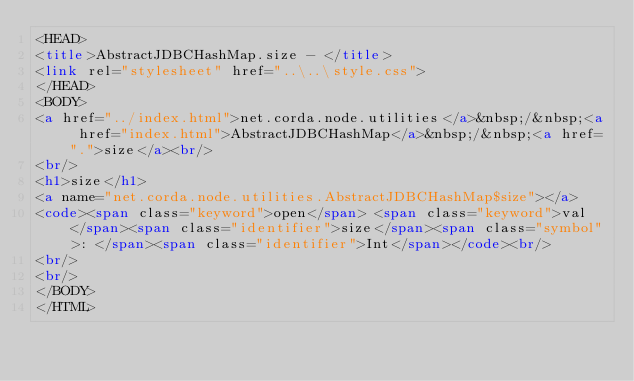Convert code to text. <code><loc_0><loc_0><loc_500><loc_500><_HTML_><HEAD>
<title>AbstractJDBCHashMap.size - </title>
<link rel="stylesheet" href="..\..\style.css">
</HEAD>
<BODY>
<a href="../index.html">net.corda.node.utilities</a>&nbsp;/&nbsp;<a href="index.html">AbstractJDBCHashMap</a>&nbsp;/&nbsp;<a href=".">size</a><br/>
<br/>
<h1>size</h1>
<a name="net.corda.node.utilities.AbstractJDBCHashMap$size"></a>
<code><span class="keyword">open</span> <span class="keyword">val </span><span class="identifier">size</span><span class="symbol">: </span><span class="identifier">Int</span></code><br/>
<br/>
<br/>
</BODY>
</HTML>
</code> 